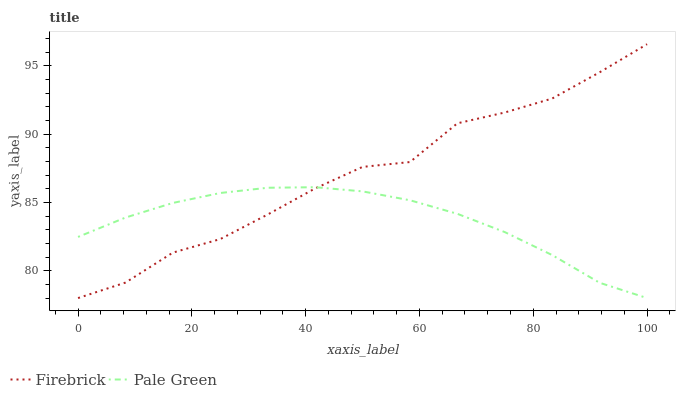Does Pale Green have the minimum area under the curve?
Answer yes or no. Yes. Does Firebrick have the maximum area under the curve?
Answer yes or no. Yes. Does Pale Green have the maximum area under the curve?
Answer yes or no. No. Is Pale Green the smoothest?
Answer yes or no. Yes. Is Firebrick the roughest?
Answer yes or no. Yes. Is Pale Green the roughest?
Answer yes or no. No. Does Firebrick have the lowest value?
Answer yes or no. Yes. Does Firebrick have the highest value?
Answer yes or no. Yes. Does Pale Green have the highest value?
Answer yes or no. No. Does Pale Green intersect Firebrick?
Answer yes or no. Yes. Is Pale Green less than Firebrick?
Answer yes or no. No. Is Pale Green greater than Firebrick?
Answer yes or no. No. 